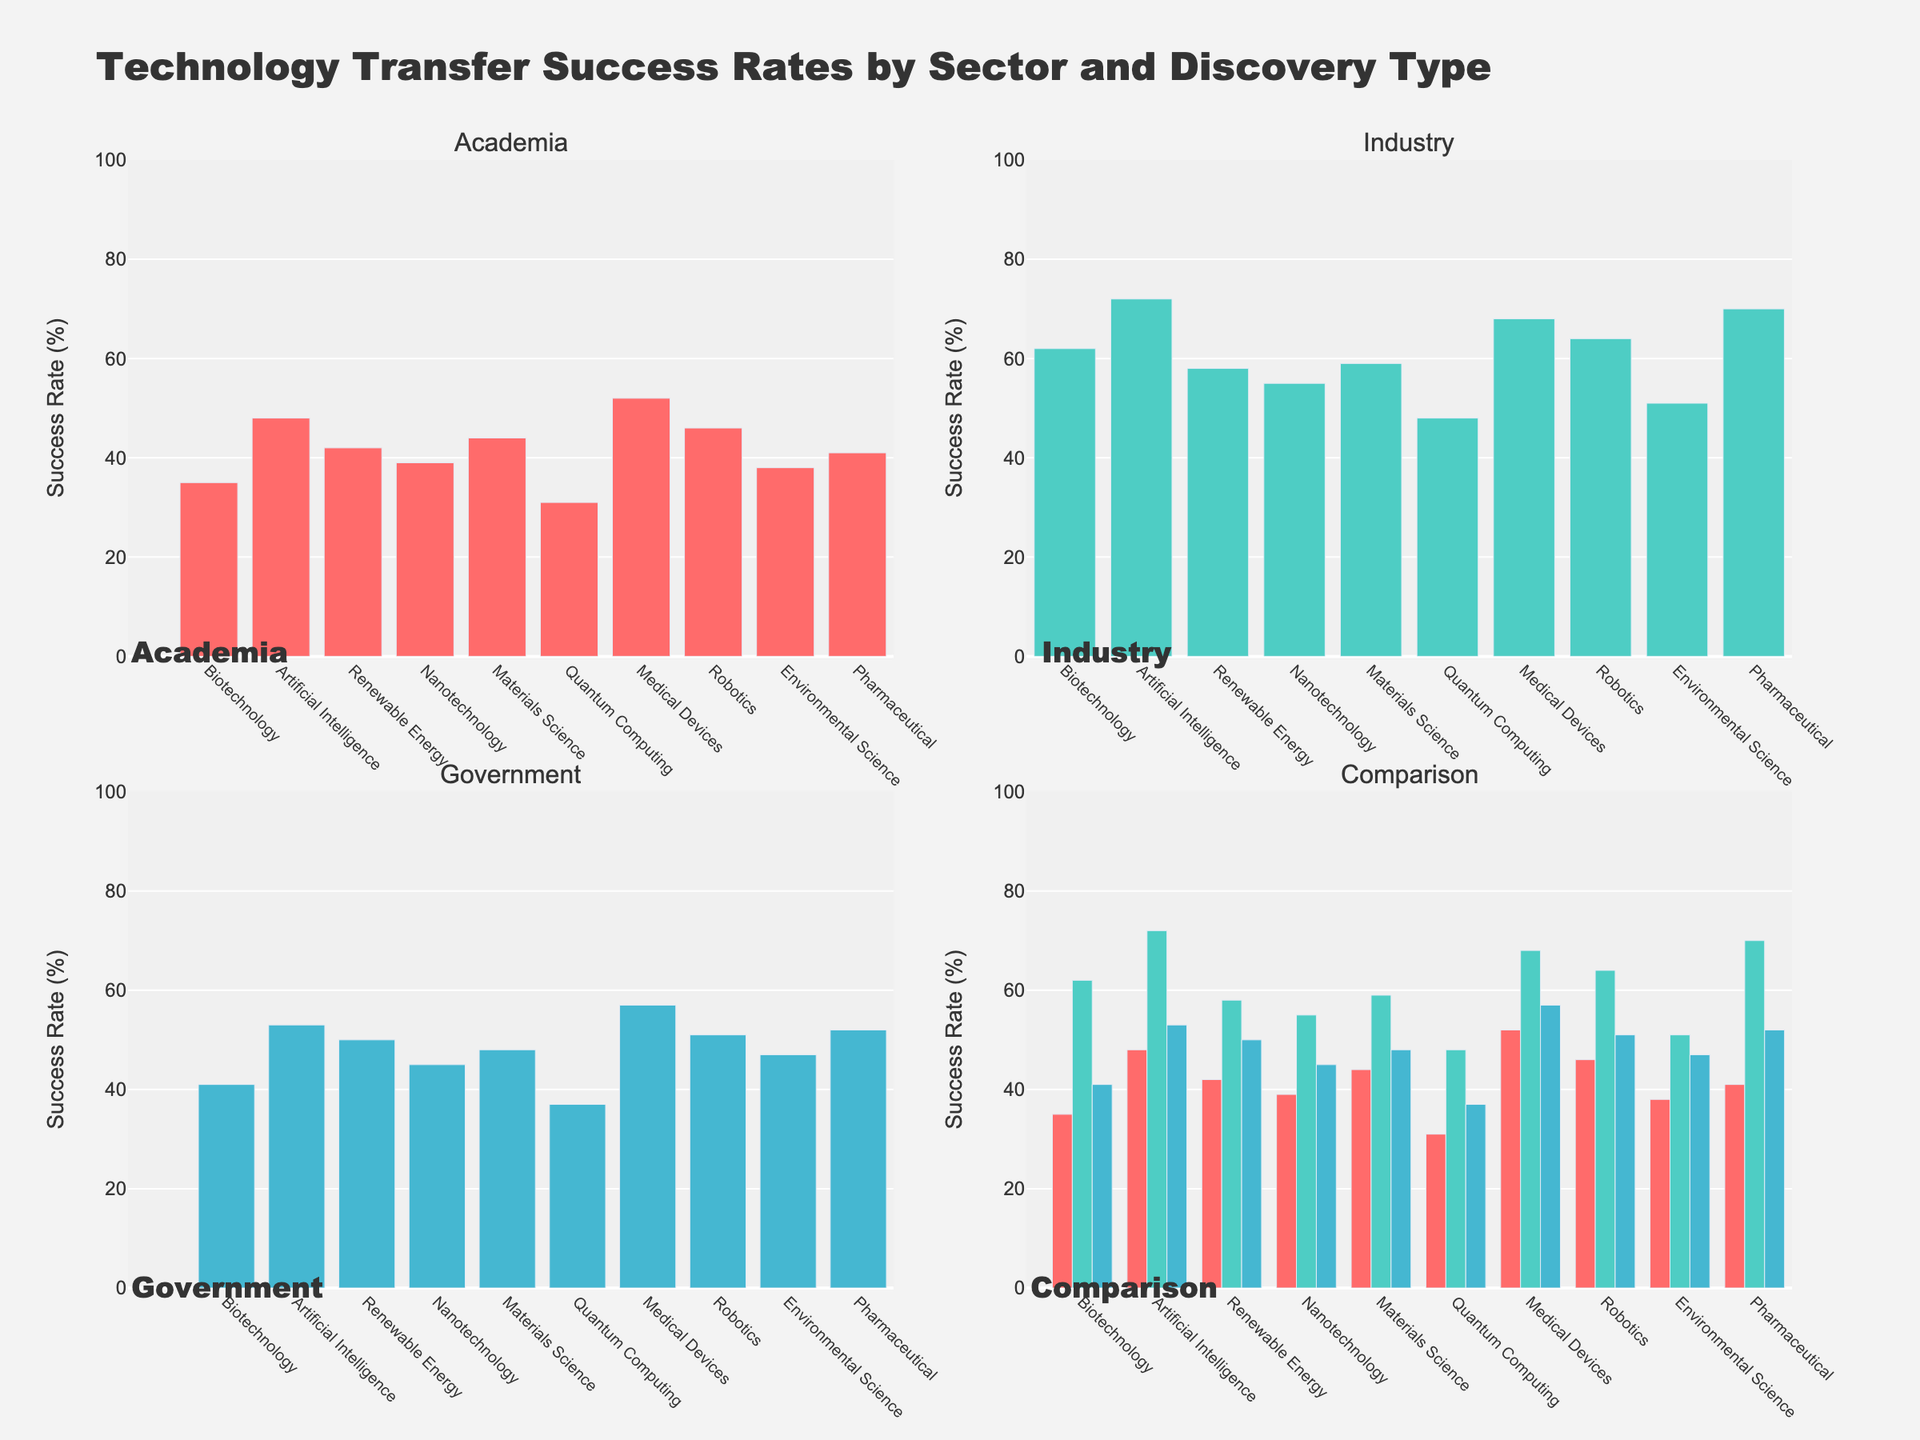What is the overall title of the figure? The overall title can be found at the top of the figure. It summarizes the content of the plots. It reads "Technology Transfer Success Rates by Sector and Discovery Type"
Answer: Technology Transfer Success Rates by Sector and Discovery Type Which sector shows the highest success rate for Biotechnology? To determine this, look at the bar heights for Biotechnology in each sector's subplot (Academia, Industry, Government). The tallest bar represents the highest success rate. The highest bar for Biotechnology is in the Industry sector
Answer: Industry What is the success rate of Artificial Intelligence in the Academia sector? Locate the subplot for Academia and find the bar corresponding to Artificial Intelligence. Read the height of the bar to determine the success rate. The bar for Artificial Intelligence in the Academia sector reaches 48
Answer: 48% What is the average success rate for Nanotechnology across all sectors? Find the success rates of Nanotechnology in Academia, Industry, and Government subplots. Add these values and divide by the number of sectors: (39 + 55 + 45) / 3
Answer: (39 + 55 + 45) / 3 = 46.33 Which discovery type has the lowest success rate in the Government sector? In the Government subplot, compare the heights of all bars. The shortest bar indicates the lowest success rate. For Government, the shortest bar is for Quantum Computing with a success rate of 37
Answer: Quantum Computing How does the success rate for Medical Devices in Academia compare to the Industry sector? Look at the bars for Medical Devices in both the Academia and Industry subplots. Compare their heights. Academia has a success rate of 52, and Industry has a rate of 68, so Industry has a higher success rate
Answer: Industry is higher (68 vs 52) Which discovery type has the most similar success rates across all sectors? Compare the bar heights for each discovery type across the Academia, Industry, and Government subplots. Identify the one with the closest values. Environmental Science has values 38, 51, 47, which are relatively close
Answer: Environmental Science What is the total success rate of Renewable Energy for all three sectors combined? Sum the success rates of Renewable Energy from all three subplots. Add the values: 42 (Academia) + 58 (Industry) + 50 (Government)
Answer: 42 + 58 + 50 = 150 Compare the success rates of Robotics in Academia and Government sectors. Which one is higher and by how much? Find the Robotics success rates in both subplots for Academia and Government. Academia has 46, and Government has 51. The difference is 51 - 46
Answer: Government is higher by 5 What discovery type experienced the most substantial difference in success rates between Academia and Industry? Identify the differences in success rates for each discovery type between Academia and Industry. Find the one with the largest gap. Comparing differences shows Biotechnology with a difference of 27 (62 - 35)
Answer: Biotechnology 